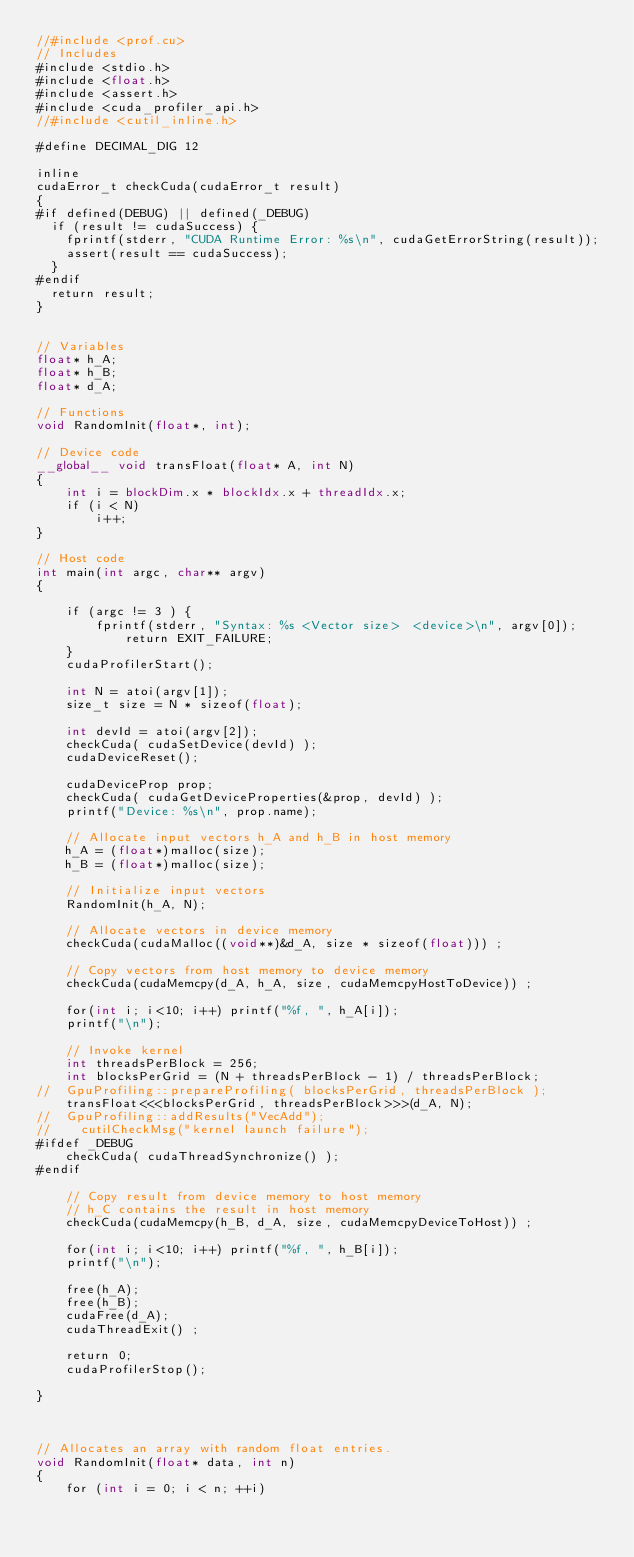<code> <loc_0><loc_0><loc_500><loc_500><_Cuda_>//#include <prof.cu>
// Includes
#include <stdio.h>
#include <float.h>
#include <assert.h>     
#include <cuda_profiler_api.h>
//#include <cutil_inline.h>

#define DECIMAL_DIG 12

inline
cudaError_t checkCuda(cudaError_t result)
{
#if defined(DEBUG) || defined(_DEBUG)
  if (result != cudaSuccess) {
    fprintf(stderr, "CUDA Runtime Error: %s\n", cudaGetErrorString(result));
    assert(result == cudaSuccess);
  }
#endif
  return result;
}


// Variables
float* h_A;
float* h_B;
float* d_A;

// Functions
void RandomInit(float*, int);

// Device code
__global__ void transFloat(float* A, int N)
{
    int i = blockDim.x * blockIdx.x + threadIdx.x;
    if (i < N)
        i++;
}

// Host code
int main(int argc, char** argv)
{

    if (argc != 3 ) {
		fprintf(stderr, "Syntax: %s <Vector size>  <device>\n", argv[0]);
    		return EXIT_FAILURE;
	}
    cudaProfilerStart();
    
    int N = atoi(argv[1]);    
    size_t size = N * sizeof(float);
    
    int devId = atoi(argv[2]);
    checkCuda( cudaSetDevice(devId) );
    cudaDeviceReset();

    cudaDeviceProp prop;
    checkCuda( cudaGetDeviceProperties(&prop, devId) );
    printf("Device: %s\n", prop.name);

    // Allocate input vectors h_A and h_B in host memory
    h_A = (float*)malloc(size);
    h_B = (float*)malloc(size);

    // Initialize input vectors
    RandomInit(h_A, N);

    // Allocate vectors in device memory
    checkCuda(cudaMalloc((void**)&d_A, size * sizeof(float))) ;

    // Copy vectors from host memory to device memory
    checkCuda(cudaMemcpy(d_A, h_A, size, cudaMemcpyHostToDevice)) ;

    for(int i; i<10; i++) printf("%f, ", h_A[i]);
    printf("\n");

    // Invoke kernel
    int threadsPerBlock = 256;
    int blocksPerGrid = (N + threadsPerBlock - 1) / threadsPerBlock;
//	GpuProfiling::prepareProfiling( blocksPerGrid, threadsPerBlock );
    transFloat<<<blocksPerGrid, threadsPerBlock>>>(d_A, N);
//	GpuProfiling::addResults("VecAdd");
//    cutilCheckMsg("kernel launch failure");
#ifdef _DEBUG
    checkCuda( cudaThreadSynchronize() );
#endif

    // Copy result from device memory to host memory
    // h_C contains the result in host memory
    checkCuda(cudaMemcpy(h_B, d_A, size, cudaMemcpyDeviceToHost)) ;

    for(int i; i<10; i++) printf("%f, ", h_B[i]);
    printf("\n");

    free(h_A);
    free(h_B);
    cudaFree(d_A);
    cudaThreadExit() ;

    return 0;
    cudaProfilerStop();

}



// Allocates an array with random float entries.
void RandomInit(float* data, int n)
{
    for (int i = 0; i < n; ++i)</code> 